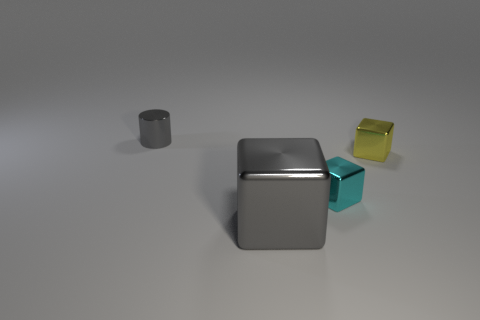What materials do the objects in the image look like they're made of? The objects in the image appear to be rendered with materials that mimic metal and glass. The cube in the foreground has a reflective surface resembling polished metal, and the cyan-colored object appears somewhat translucent, like frosted glass. The small cube in the back has a matte finish suggesting a plastic or glass material with a yellow tint. 